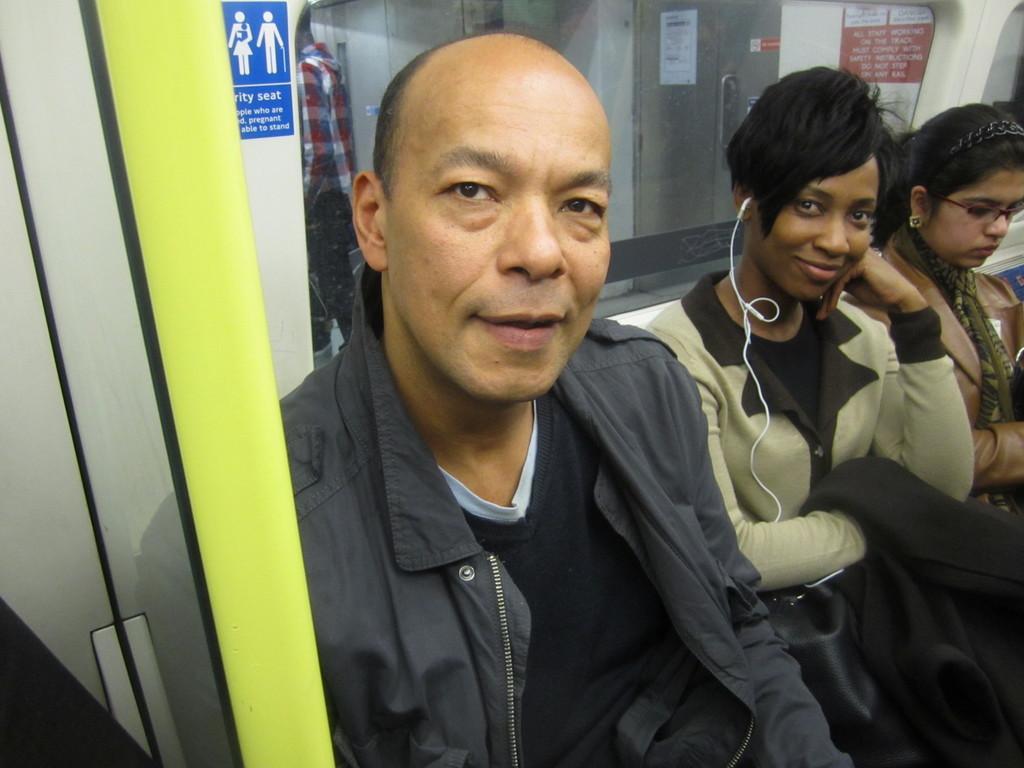Can you describe this image briefly? In this image in the center there are persons sitting and smiling. In the background there is a poster with some text written on it and there is a person standing. 